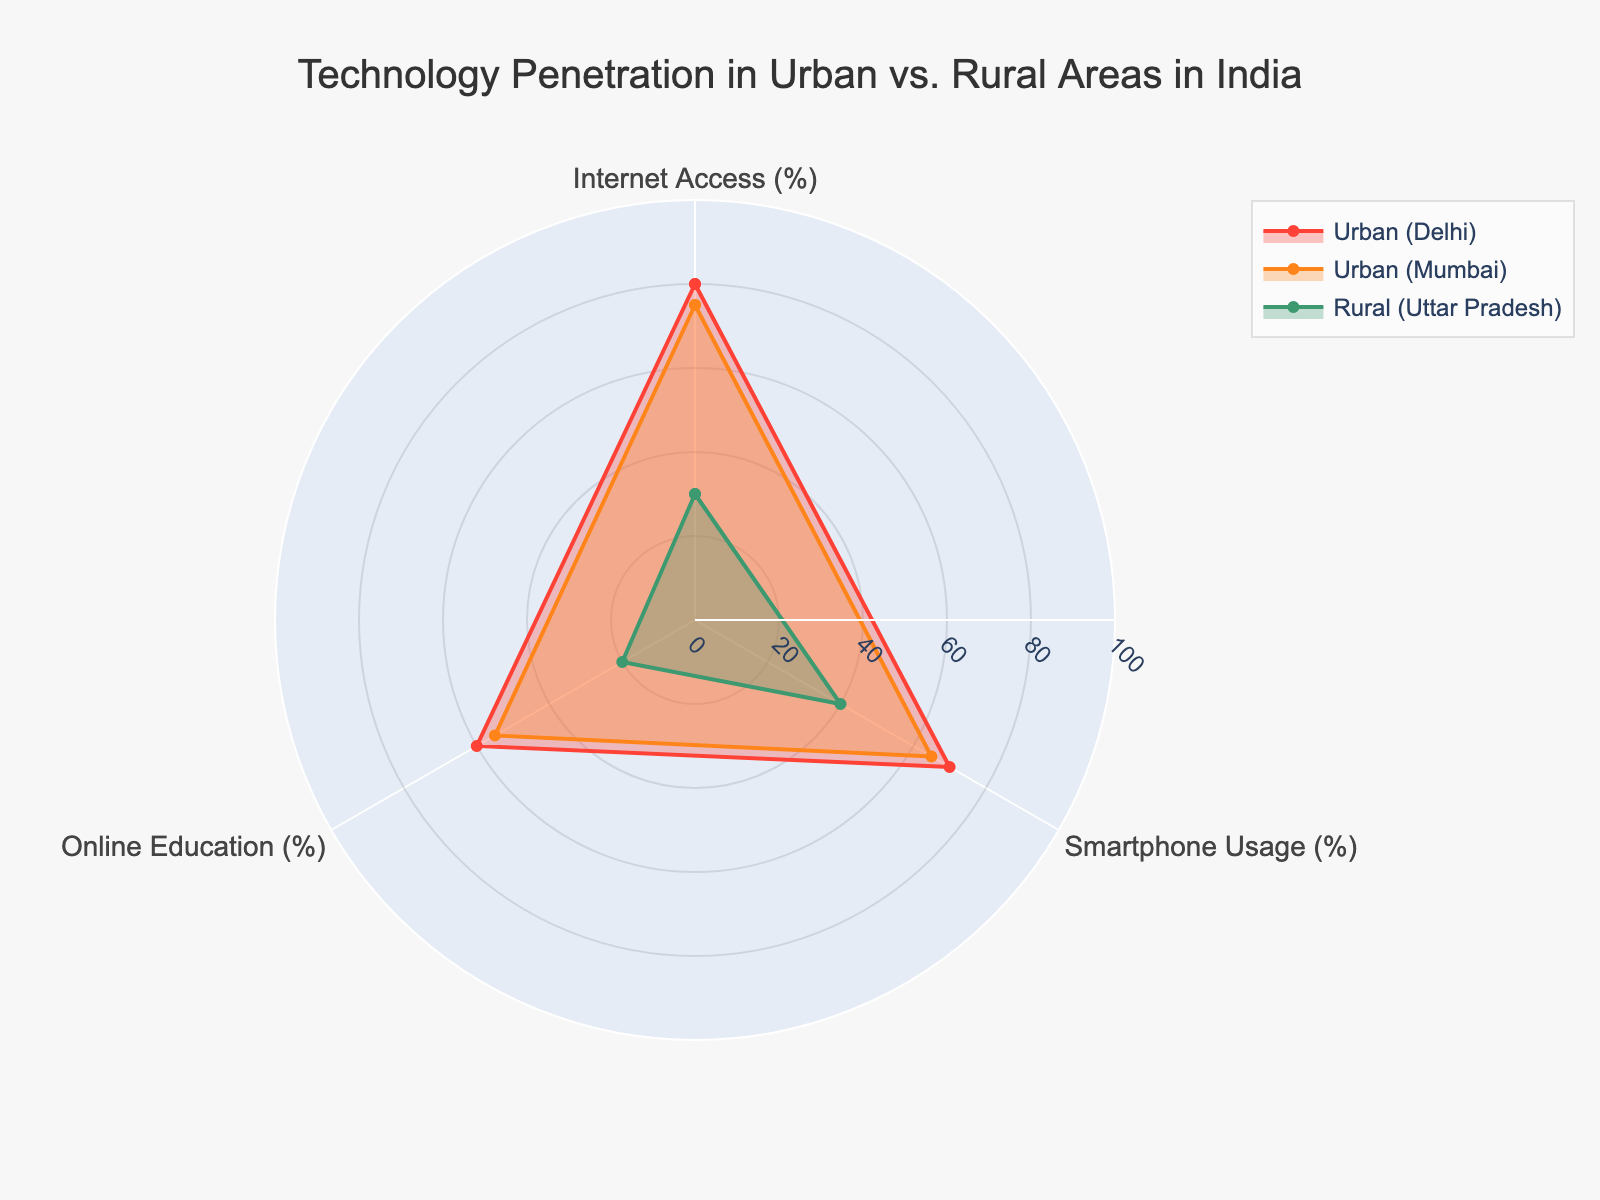Which group has the highest Internet access? First, locate the category "Internet Access" on the radar chart. Next, observe the corresponding values for each group. Urban (Delhi) has 80%, Urban (Mumbai) has 75%, Rural (Uttar Pradesh) has 30%, and Rural (Bihar) has 25%. The highest percentage is 80%.
Answer: Urban (Delhi) How much higher is smartphone usage in Urban (Delhi) compared to Rural (Bihar)? Locate the "Smartphone Usage" category on the radar chart. Urban (Delhi) has 70% and Rural (Bihar) has 35%. Subtract the Rural (Bihar) percentage from the Urban (Delhi) percentage: 70% - 35% = 35%.
Answer: 35% Which technology shows the largest penetration gap between urban and rural areas in India? Compare the gaps for each technology by subtracting rural values from urban values: For Internet Access, the largest urban value is Urban (Delhi) at 80%, and the smallest rural value is Rural (Bihar) at 25%, a gap of 55%. For Smartphone Usage, the gap is 70% - 35% = 35%. For Online Education, the gap is 60% - 15% = 45%. The largest gap is 55% for Internet Access.
Answer: Internet Access What is the average percentage of online education usage across all groups? Sum the Online Education values for all groups: 60% (Urban Delhi) + 55% (Urban Mumbai) + 20% (Rural Uttar Pradesh) + 15% (Rural Bihar) = 150%. Divide by the number of groups: 150% / 4 = 37.5%.
Answer: 37.5% Which technology has the smallest difference in penetration between Urban (Delhi) and Urban (Mumbai)? For Internet Access: 80% (Urban Delhi) - 75% (Urban Mumbai) = 5%. For Smartphone Usage: 70% - 65% = 5%. For Online Education: 60% - 55% = 5%. The differences are the same for all technologies, 5%.
Answer: All have the same difference Between which urban and rural pair is the gap in internet access larger, Urban (Delhi) and Rural (Uttar Pradesh) or Urban (Mumbai) and Rural (Bihar)? For Urban (Delhi) and Rural (Uttar Pradesh): 80% - 30% = 50%. For Urban (Mumbai) and Rural (Bihar): 75% - 25% = 50%. Both gaps are equal at 50%.
Answer: Both are equal Does any group have higher smartphone usage compared to Internet access? Compare the values for each group: Urban (Delhi) has 70% smartphone usage vs 80% Internet access, Urban (Mumbai) 65% vs 75%, Rural (Uttar Pradesh) 40% vs 30%, Rural (Bihar) 35% vs 25%. Only Rural (Uttar Pradesh) shows higher smartphone usage compared to Internet access.
Answer: Rural (Uttar Pradesh) Which rural area has a higher rate of online education usage, Uttar Pradesh or Bihar? Compare the values for Online Education: Rural (Uttar Pradesh) has 20% and Rural (Bihar) has 15%. 20% is greater than 15%.
Answer: Rural (Uttar Pradesh) What is the combined penetration rate for Internet access and smartphone usage in Urban (Mumbai)? Add Internet Access and Smartphone Usage percentages for Urban (Mumbai): 75% + 65% = 140%.
Answer: 140% In which category is the technology penetration gap between the highest and lowest overall values the largest? Compare overall values for each category: For Internet Access, highest is 80% (Urban Delhi) and lowest is 25% (Rural Bihar), gap is 55%. For Smartphone Usage, highest is 70% (Urban Delhi) and lowest is 35% (Rural Bihar), gap is 35%. For Online Education, highest is 60% (Urban Delhi) and lowest is 15% (Rural Bihar), gap is 45%. The largest gap is 55% for Internet Access.
Answer: Internet Access 